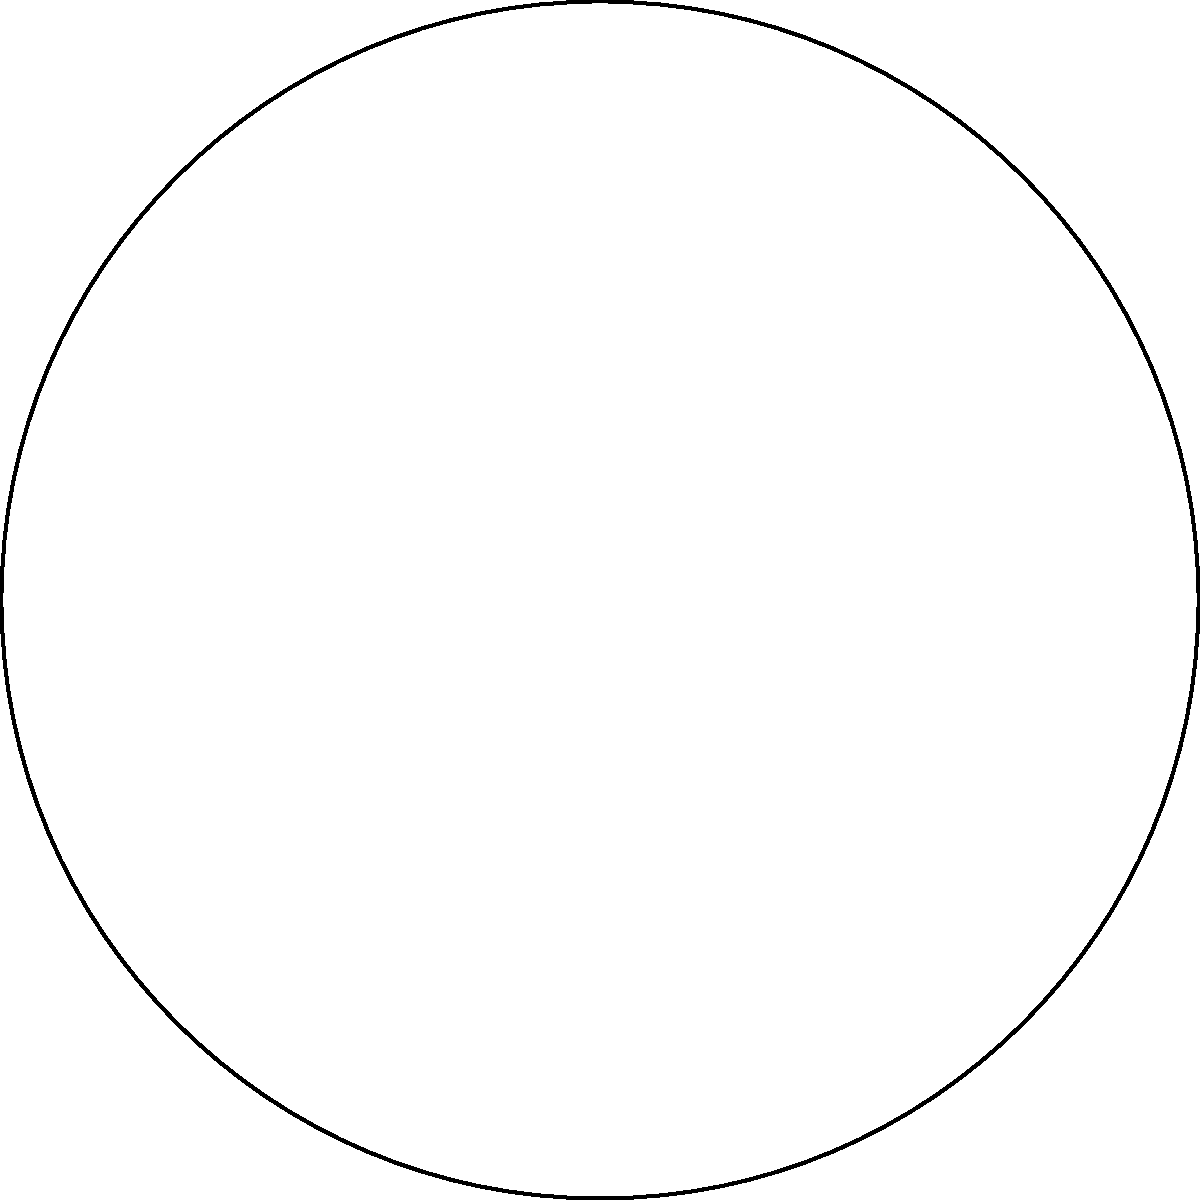In the figure above, a regular octagon is inscribed in a circle with radius $r$. Calculate the perimeter of the octagon in terms of $r$. How does this shape's symmetry reflect the importance of equal representation in gender equality movements? Let's approach this step-by-step:

1) In a regular octagon, all sides are equal. Let's call the side length $s$.

2) The octagon can be divided into 8 congruent triangles, each with two radii as sides and $s$ as the base.

3) The central angle of each triangle is $\frac{360°}{8} = 45°$.

4) In one of these triangles, we can use the trigonometric ratio:

   $$\sin(22.5°) = \frac{s/2}{r}$$

5) Solving for $s$:

   $$s = 2r \sin(22.5°)$$

6) The perimeter of the octagon is 8 times this side length:

   $$\text{Perimeter} = 8s = 8(2r \sin(22.5°)) = 16r \sin(22.5°)$$

7) We can simplify this further using the trigonometric identity:

   $$\sin(22.5°) = \frac{\sqrt{2-\sqrt{2}}}{2}$$

8) Substituting this in:

   $$\text{Perimeter} = 16r \cdot \frac{\sqrt{2-\sqrt{2}}}{2} = 8r\sqrt{2-\sqrt{2}}$$

This octagon's symmetry, with all sides and angles equal, reflects the core principle of gender equality: all individuals, regardless of their gender identity, deserve equal rights, opportunities, and representation. Just as each side of the octagon contributes equally to its perimeter, each person's voice and experience is equally valuable in the movement for gender equality.
Answer: $8r\sqrt{2-\sqrt{2}}$ 